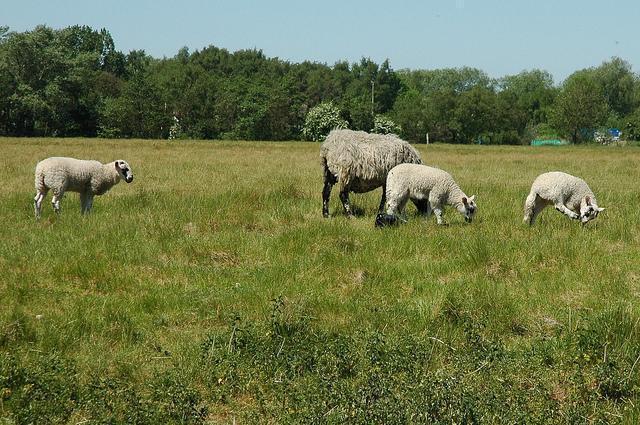What meal would these animals prefer?
Answer the question by selecting the correct answer among the 4 following choices.
Options: Salad, fish cakes, venison, rabbit stew. Salad. 